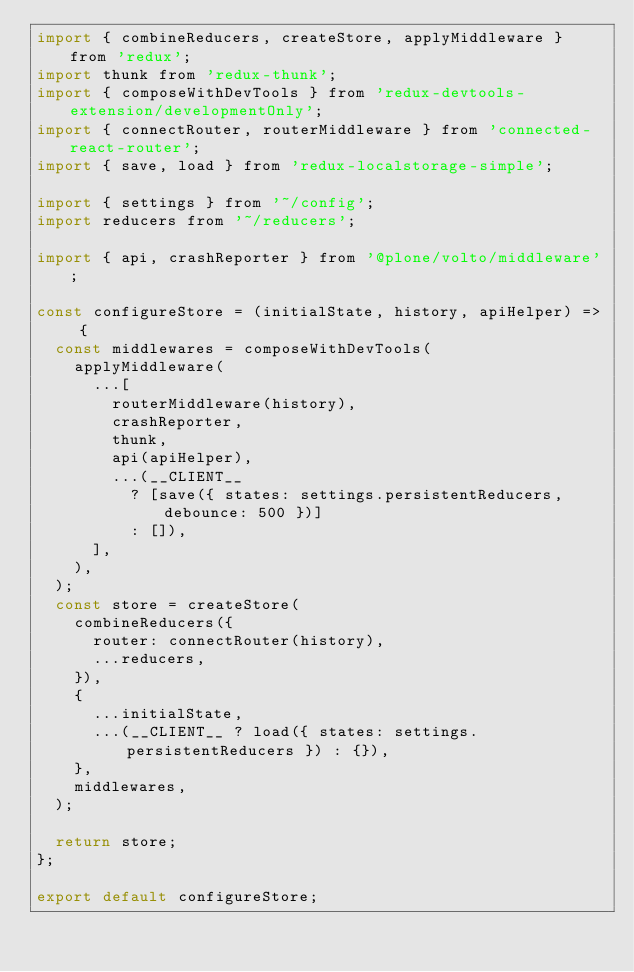Convert code to text. <code><loc_0><loc_0><loc_500><loc_500><_JavaScript_>import { combineReducers, createStore, applyMiddleware } from 'redux';
import thunk from 'redux-thunk';
import { composeWithDevTools } from 'redux-devtools-extension/developmentOnly';
import { connectRouter, routerMiddleware } from 'connected-react-router';
import { save, load } from 'redux-localstorage-simple';

import { settings } from '~/config';
import reducers from '~/reducers';

import { api, crashReporter } from '@plone/volto/middleware';

const configureStore = (initialState, history, apiHelper) => {
  const middlewares = composeWithDevTools(
    applyMiddleware(
      ...[
        routerMiddleware(history),
        crashReporter,
        thunk,
        api(apiHelper),
        ...(__CLIENT__
          ? [save({ states: settings.persistentReducers, debounce: 500 })]
          : []),
      ],
    ),
  );
  const store = createStore(
    combineReducers({
      router: connectRouter(history),
      ...reducers,
    }),
    {
      ...initialState,
      ...(__CLIENT__ ? load({ states: settings.persistentReducers }) : {}),
    },
    middlewares,
  );

  return store;
};

export default configureStore;
</code> 